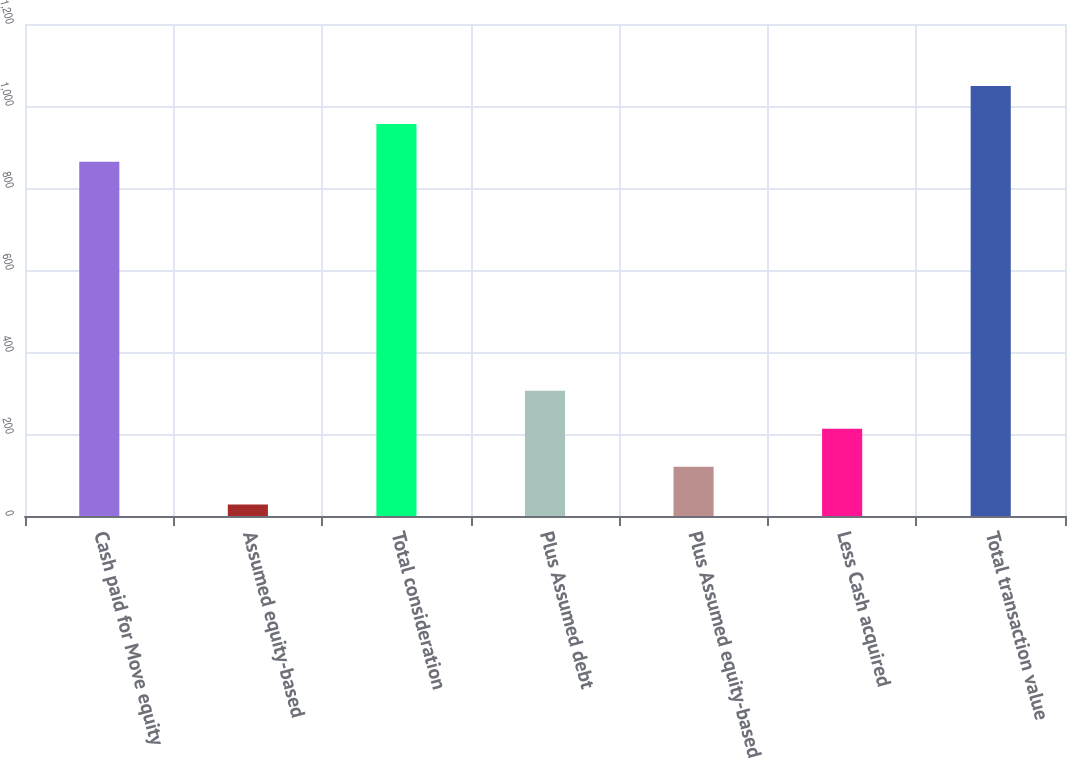<chart> <loc_0><loc_0><loc_500><loc_500><bar_chart><fcel>Cash paid for Move equity<fcel>Assumed equity-based<fcel>Total consideration<fcel>Plus Assumed debt<fcel>Plus Assumed equity-based<fcel>Less Cash acquired<fcel>Total transaction value<nl><fcel>864<fcel>28<fcel>956.4<fcel>305.2<fcel>120.4<fcel>212.8<fcel>1048.8<nl></chart> 